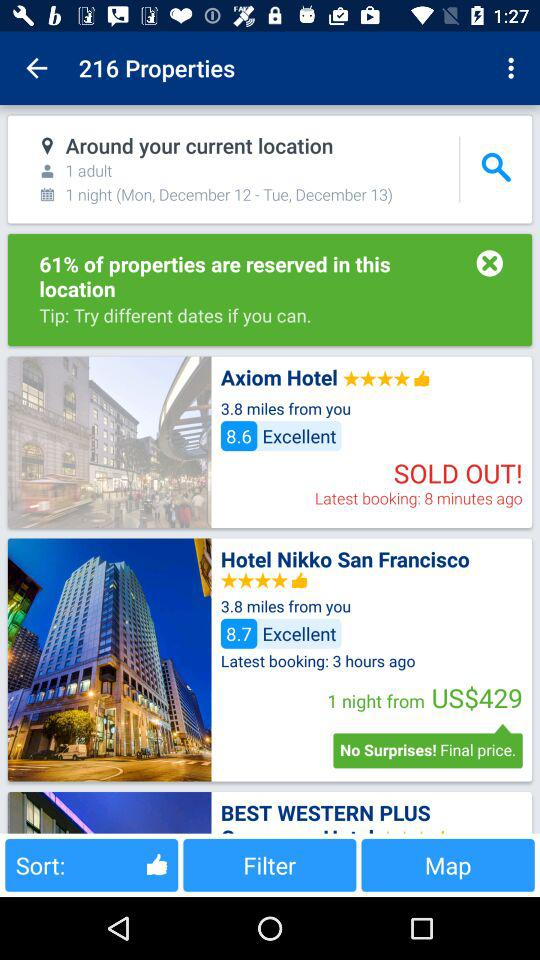What is the address?
When the provided information is insufficient, respond with <no answer>. <no answer> 